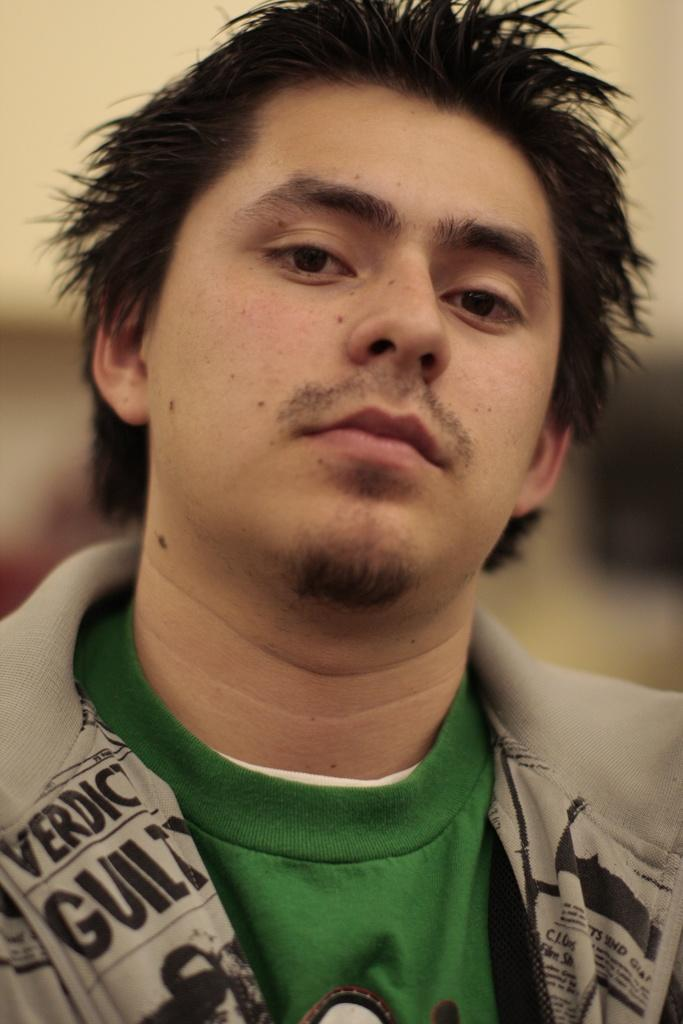Who is present in the image? There is a man in the image. What can be observed about the background of the image? The background of the image is blurred. What type of government is depicted in the image? There is no depiction of a government in the image; it features a man and a blurred background. How comfortable is the chair the man is sitting on in the image? The image does not provide enough information to determine the comfort level of the chair the man is sitting on. 